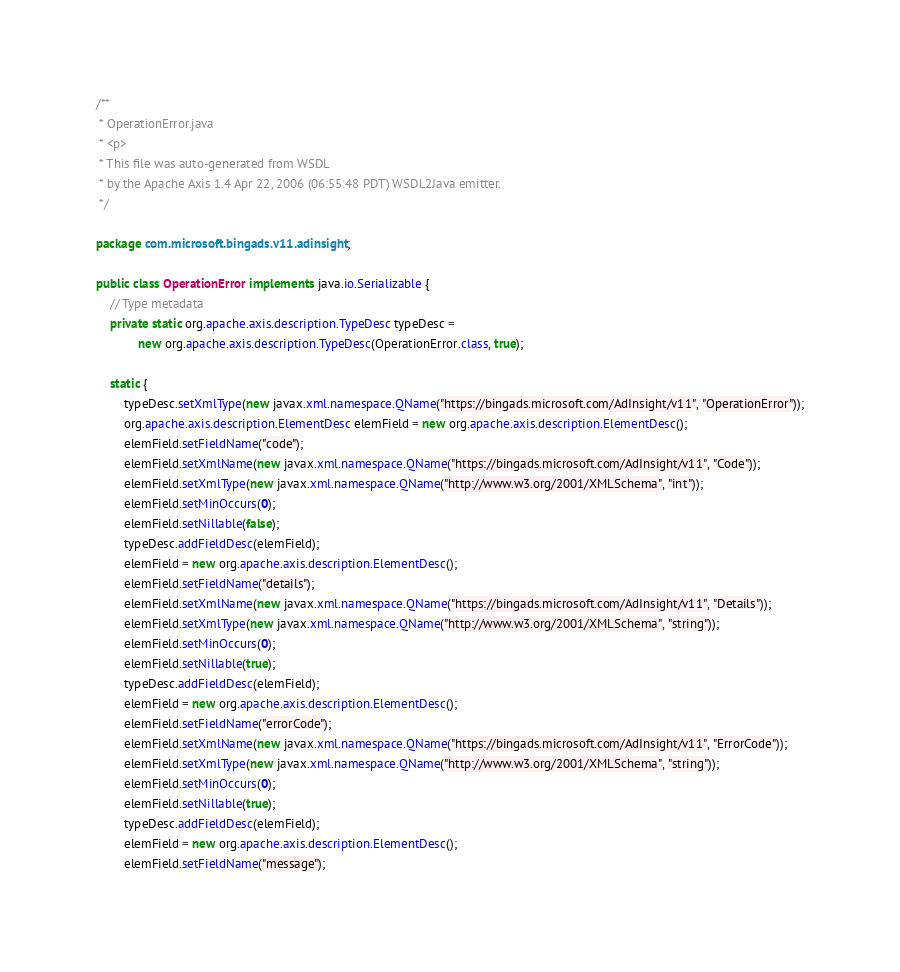<code> <loc_0><loc_0><loc_500><loc_500><_Java_>/**
 * OperationError.java
 * <p>
 * This file was auto-generated from WSDL
 * by the Apache Axis 1.4 Apr 22, 2006 (06:55:48 PDT) WSDL2Java emitter.
 */

package com.microsoft.bingads.v11.adinsight;

public class OperationError implements java.io.Serializable {
    // Type metadata
    private static org.apache.axis.description.TypeDesc typeDesc =
            new org.apache.axis.description.TypeDesc(OperationError.class, true);

    static {
        typeDesc.setXmlType(new javax.xml.namespace.QName("https://bingads.microsoft.com/AdInsight/v11", "OperationError"));
        org.apache.axis.description.ElementDesc elemField = new org.apache.axis.description.ElementDesc();
        elemField.setFieldName("code");
        elemField.setXmlName(new javax.xml.namespace.QName("https://bingads.microsoft.com/AdInsight/v11", "Code"));
        elemField.setXmlType(new javax.xml.namespace.QName("http://www.w3.org/2001/XMLSchema", "int"));
        elemField.setMinOccurs(0);
        elemField.setNillable(false);
        typeDesc.addFieldDesc(elemField);
        elemField = new org.apache.axis.description.ElementDesc();
        elemField.setFieldName("details");
        elemField.setXmlName(new javax.xml.namespace.QName("https://bingads.microsoft.com/AdInsight/v11", "Details"));
        elemField.setXmlType(new javax.xml.namespace.QName("http://www.w3.org/2001/XMLSchema", "string"));
        elemField.setMinOccurs(0);
        elemField.setNillable(true);
        typeDesc.addFieldDesc(elemField);
        elemField = new org.apache.axis.description.ElementDesc();
        elemField.setFieldName("errorCode");
        elemField.setXmlName(new javax.xml.namespace.QName("https://bingads.microsoft.com/AdInsight/v11", "ErrorCode"));
        elemField.setXmlType(new javax.xml.namespace.QName("http://www.w3.org/2001/XMLSchema", "string"));
        elemField.setMinOccurs(0);
        elemField.setNillable(true);
        typeDesc.addFieldDesc(elemField);
        elemField = new org.apache.axis.description.ElementDesc();
        elemField.setFieldName("message");</code> 